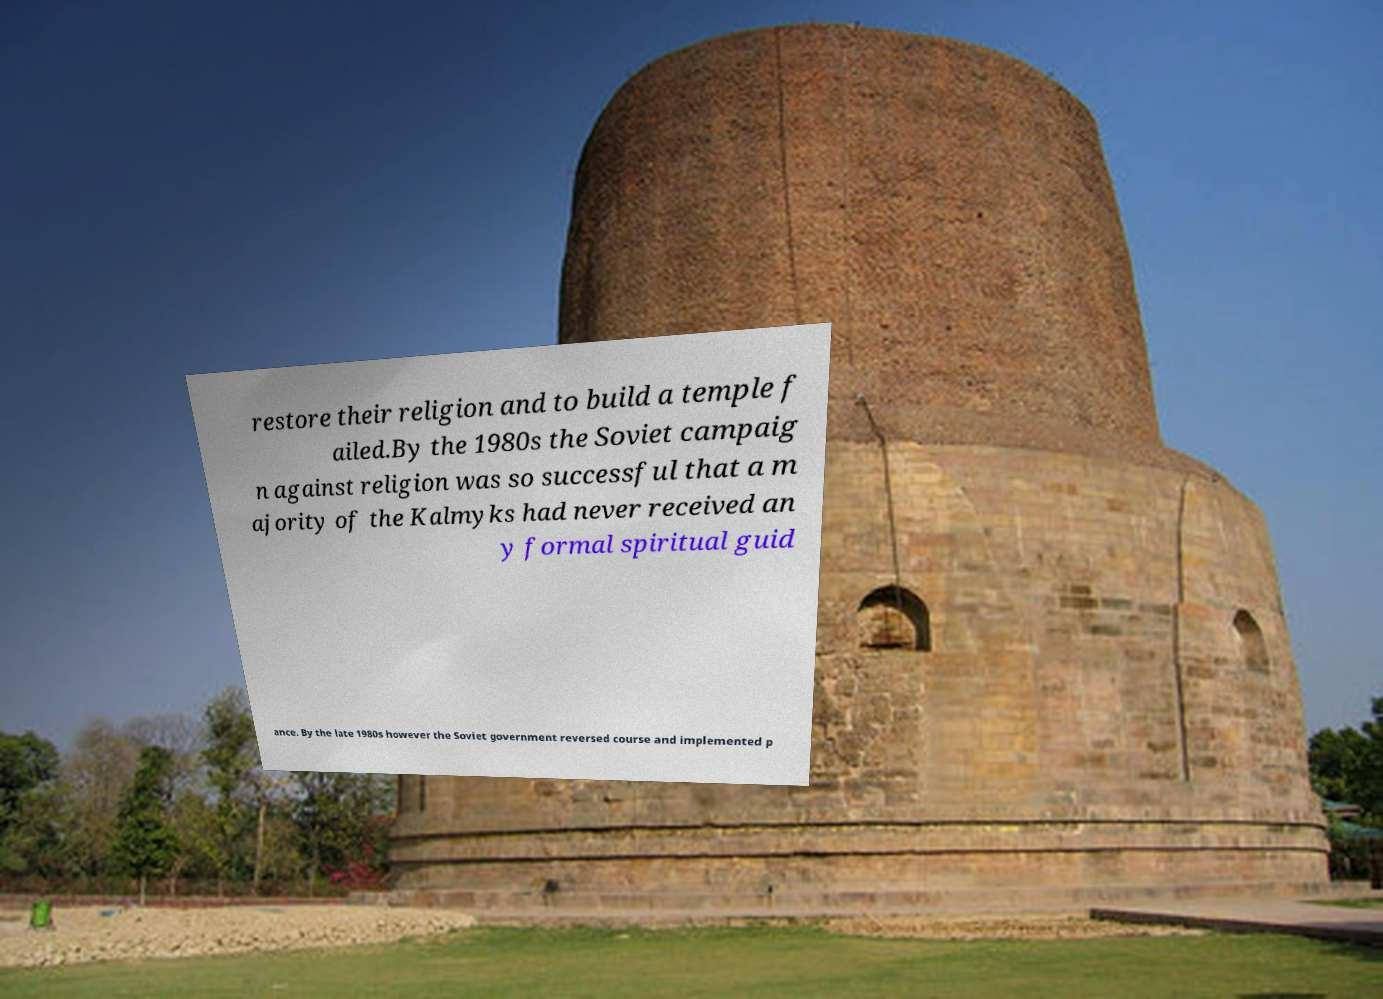Can you read and provide the text displayed in the image?This photo seems to have some interesting text. Can you extract and type it out for me? restore their religion and to build a temple f ailed.By the 1980s the Soviet campaig n against religion was so successful that a m ajority of the Kalmyks had never received an y formal spiritual guid ance. By the late 1980s however the Soviet government reversed course and implemented p 